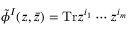<formula> <loc_0><loc_0><loc_500><loc_500>\tilde { \phi } ^ { I } ( z , \bar { z } ) = T r z ^ { i _ { 1 } } \cdots z ^ { i _ { m } }</formula> 